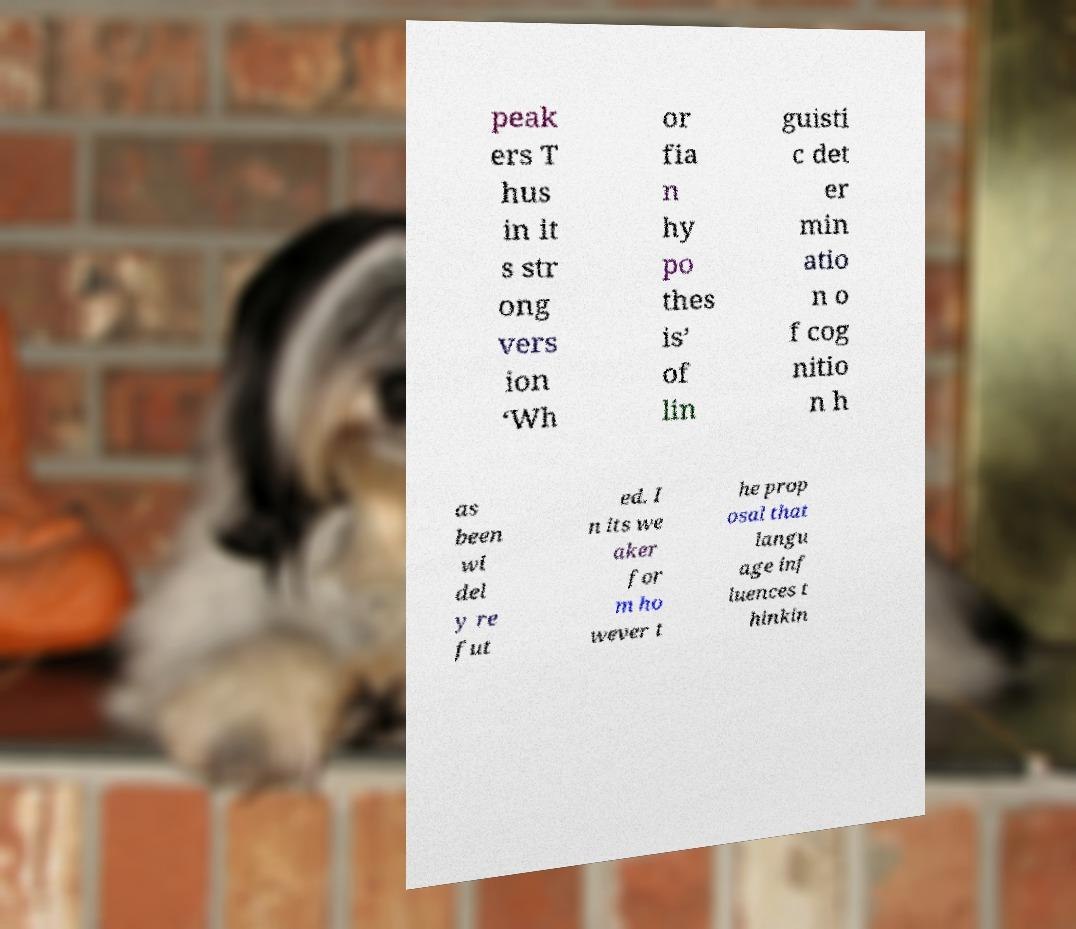Can you accurately transcribe the text from the provided image for me? peak ers T hus in it s str ong vers ion ‘Wh or fia n hy po thes is’ of lin guisti c det er min atio n o f cog nitio n h as been wi del y re fut ed. I n its we aker for m ho wever t he prop osal that langu age inf luences t hinkin 